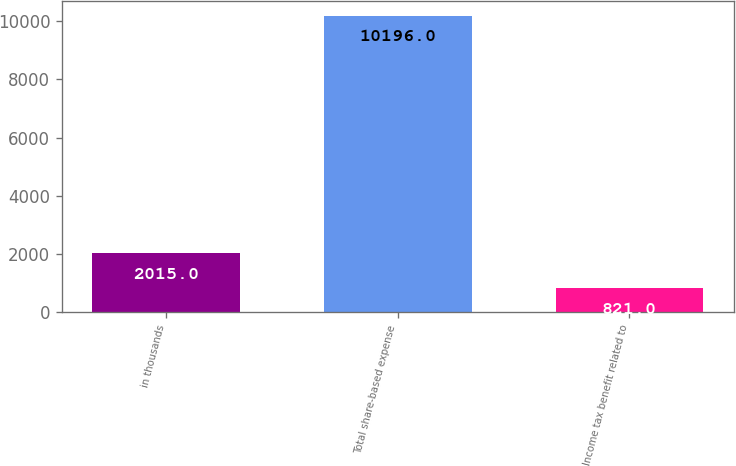Convert chart to OTSL. <chart><loc_0><loc_0><loc_500><loc_500><bar_chart><fcel>in thousands<fcel>Total share-based expense<fcel>Income tax benefit related to<nl><fcel>2015<fcel>10196<fcel>821<nl></chart> 